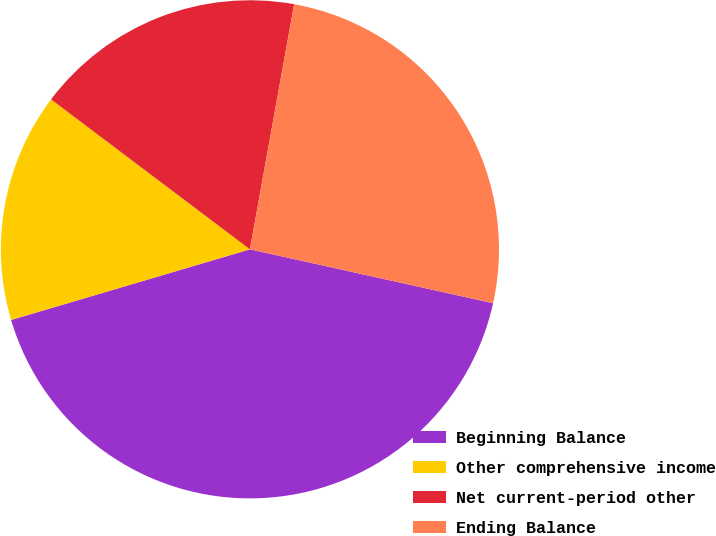<chart> <loc_0><loc_0><loc_500><loc_500><pie_chart><fcel>Beginning Balance<fcel>Other comprehensive income<fcel>Net current-period other<fcel>Ending Balance<nl><fcel>41.95%<fcel>14.86%<fcel>17.56%<fcel>25.63%<nl></chart> 